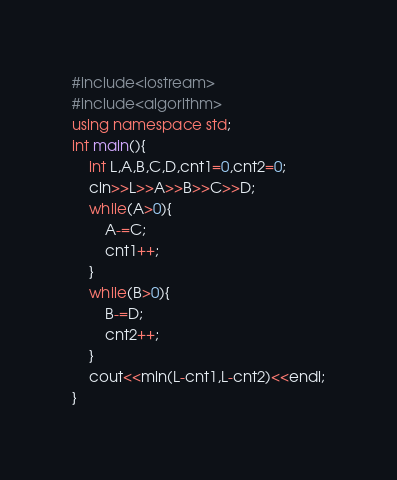Convert code to text. <code><loc_0><loc_0><loc_500><loc_500><_C++_>#include<iostream>
#include<algorithm>
using namespace std;
int main(){
	int L,A,B,C,D,cnt1=0,cnt2=0;
	cin>>L>>A>>B>>C>>D;
	while(A>0){
		A-=C;
		cnt1++;
	}
	while(B>0){
		B-=D;
		cnt2++;
	}
	cout<<min(L-cnt1,L-cnt2)<<endl;
}</code> 